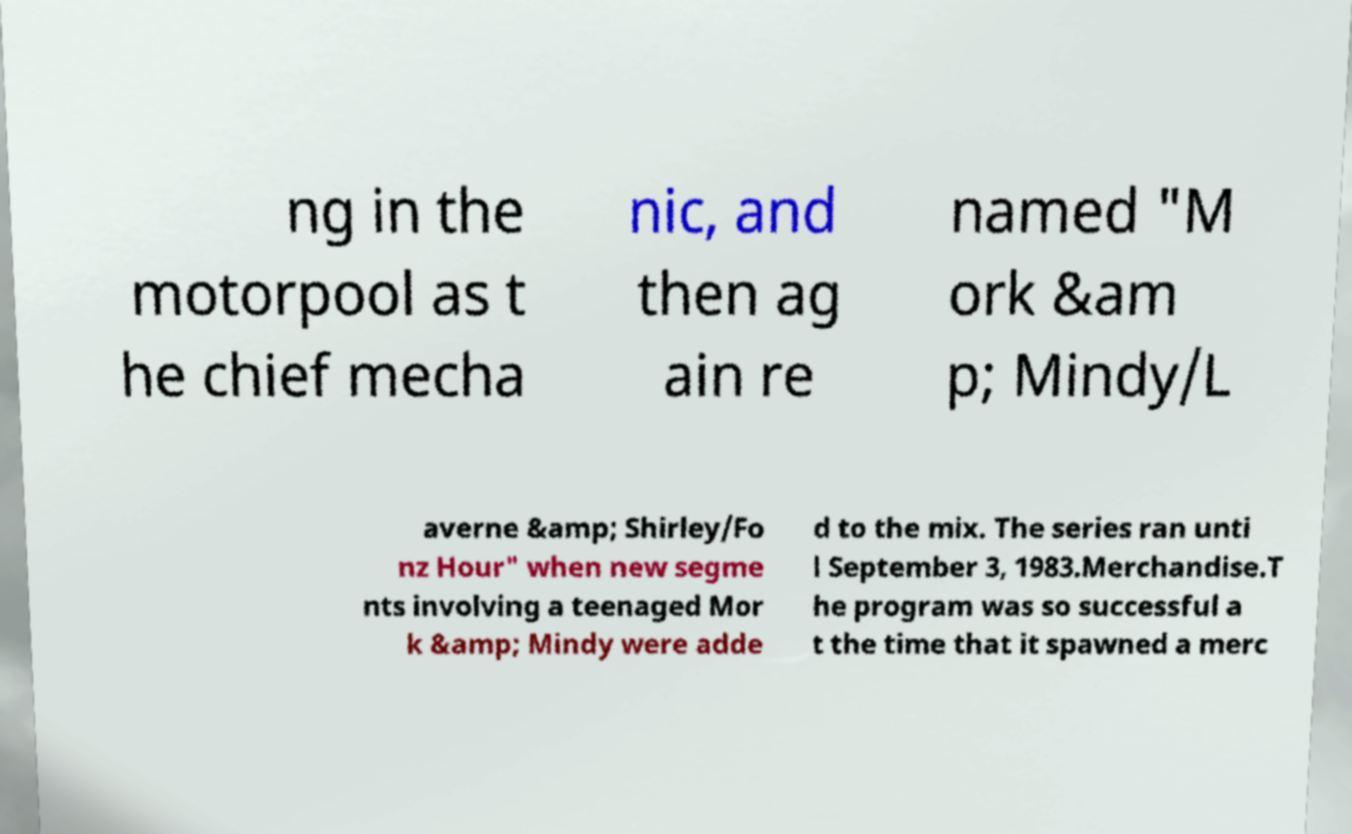Please read and relay the text visible in this image. What does it say? ng in the motorpool as t he chief mecha nic, and then ag ain re named "M ork &am p; Mindy/L averne &amp; Shirley/Fo nz Hour" when new segme nts involving a teenaged Mor k &amp; Mindy were adde d to the mix. The series ran unti l September 3, 1983.Merchandise.T he program was so successful a t the time that it spawned a merc 